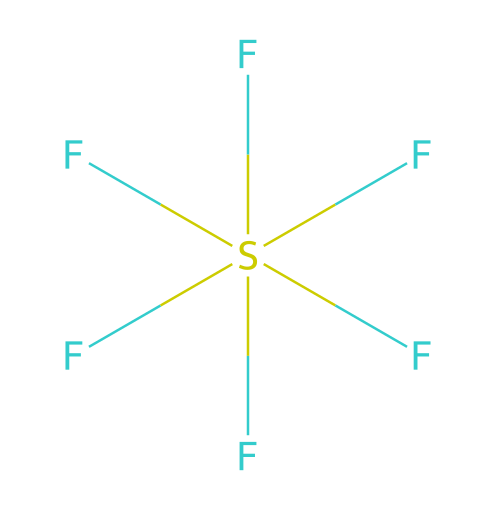What is the molecular formula of this compound? The chemical is represented by the SMILES notation F[S](F)(F)(F)(F)F, which indicates that there is one sulfur atom and six fluorine atoms. Hence, the molecular formula is derived directly from these counts.
Answer: SF6 How many valence electrons does sulfur contribute to this molecule? Sulfur is in group 16 of the periodic table and has six valence electrons. This fact allows us to identify how many electrons sulfur contributes to forming bonds in the molecule.
Answer: 6 What type of bonding exists between sulfur and fluorine in this compound? The interactions between sulfur and fluorine are covalent bonds formed through the sharing of electrons. These bonds arise due to the need for sulfur to accommodate more than eight electrons in its valence shell, characteristic of hypervalent compounds.
Answer: covalent How many total bonds are present in this molecule? Given that sulfur is bonded to six fluorine atoms via single covalent bonds, we can count these bonds directly. Each F atom forms one bond with S, leading to a total of six bonds.
Answer: 6 What structural feature allows sulfur to exceed the octet rule in this compound? Sulfur can expand its valence shell and utilize available d-orbitals for bonding, allowing it to accommodate more than eight electrons. This capacity is characteristic of hypervalent compounds, such as SF6.
Answer: d-orbitals How many lone pairs of electrons are present on the sulfur atom? The sulfur atom in SF6 does not have any lone pairs of electrons; it is fully bonded with six fluorine atoms, which consume all available electrons in bonding. Each bond utilizes one electron from sulfur.
Answer: 0 What is the molecular geometry of this compound? The arrangement of six fluorine atoms around a central sulfur atom exhibits an octahedral geometry due to the symmetrical distribution of the equatorial and axial positions in a three-dimensional space.
Answer: octahedral 